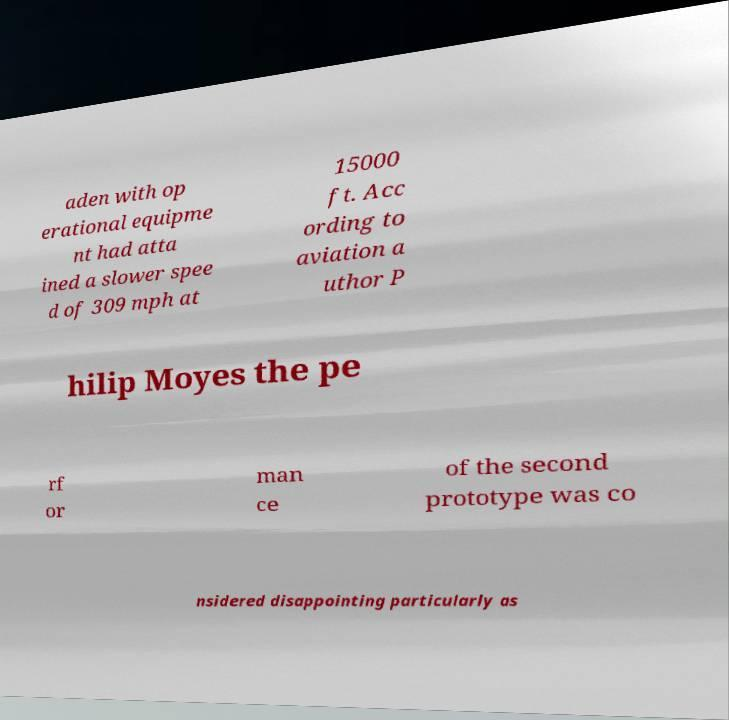Please identify and transcribe the text found in this image. aden with op erational equipme nt had atta ined a slower spee d of 309 mph at 15000 ft. Acc ording to aviation a uthor P hilip Moyes the pe rf or man ce of the second prototype was co nsidered disappointing particularly as 